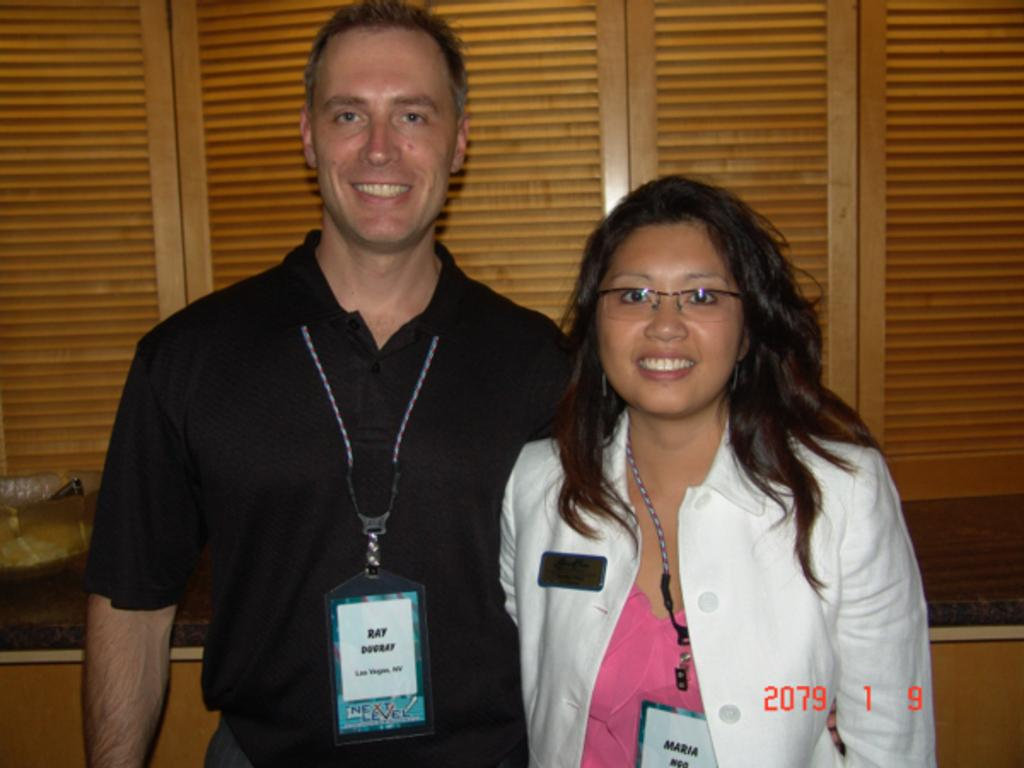How many people are present in the image? There are two people in the image. Can you describe one of the people in the image? One of the people is a lady. What is the lady wearing in the image? The lady is wearing a jacket. What do both people have in common in the image? Both people are wearing tags. Can you tell me how much the lady's jacket stretches in the image? The image does not provide information about the stretchiness of the lady's jacket. 